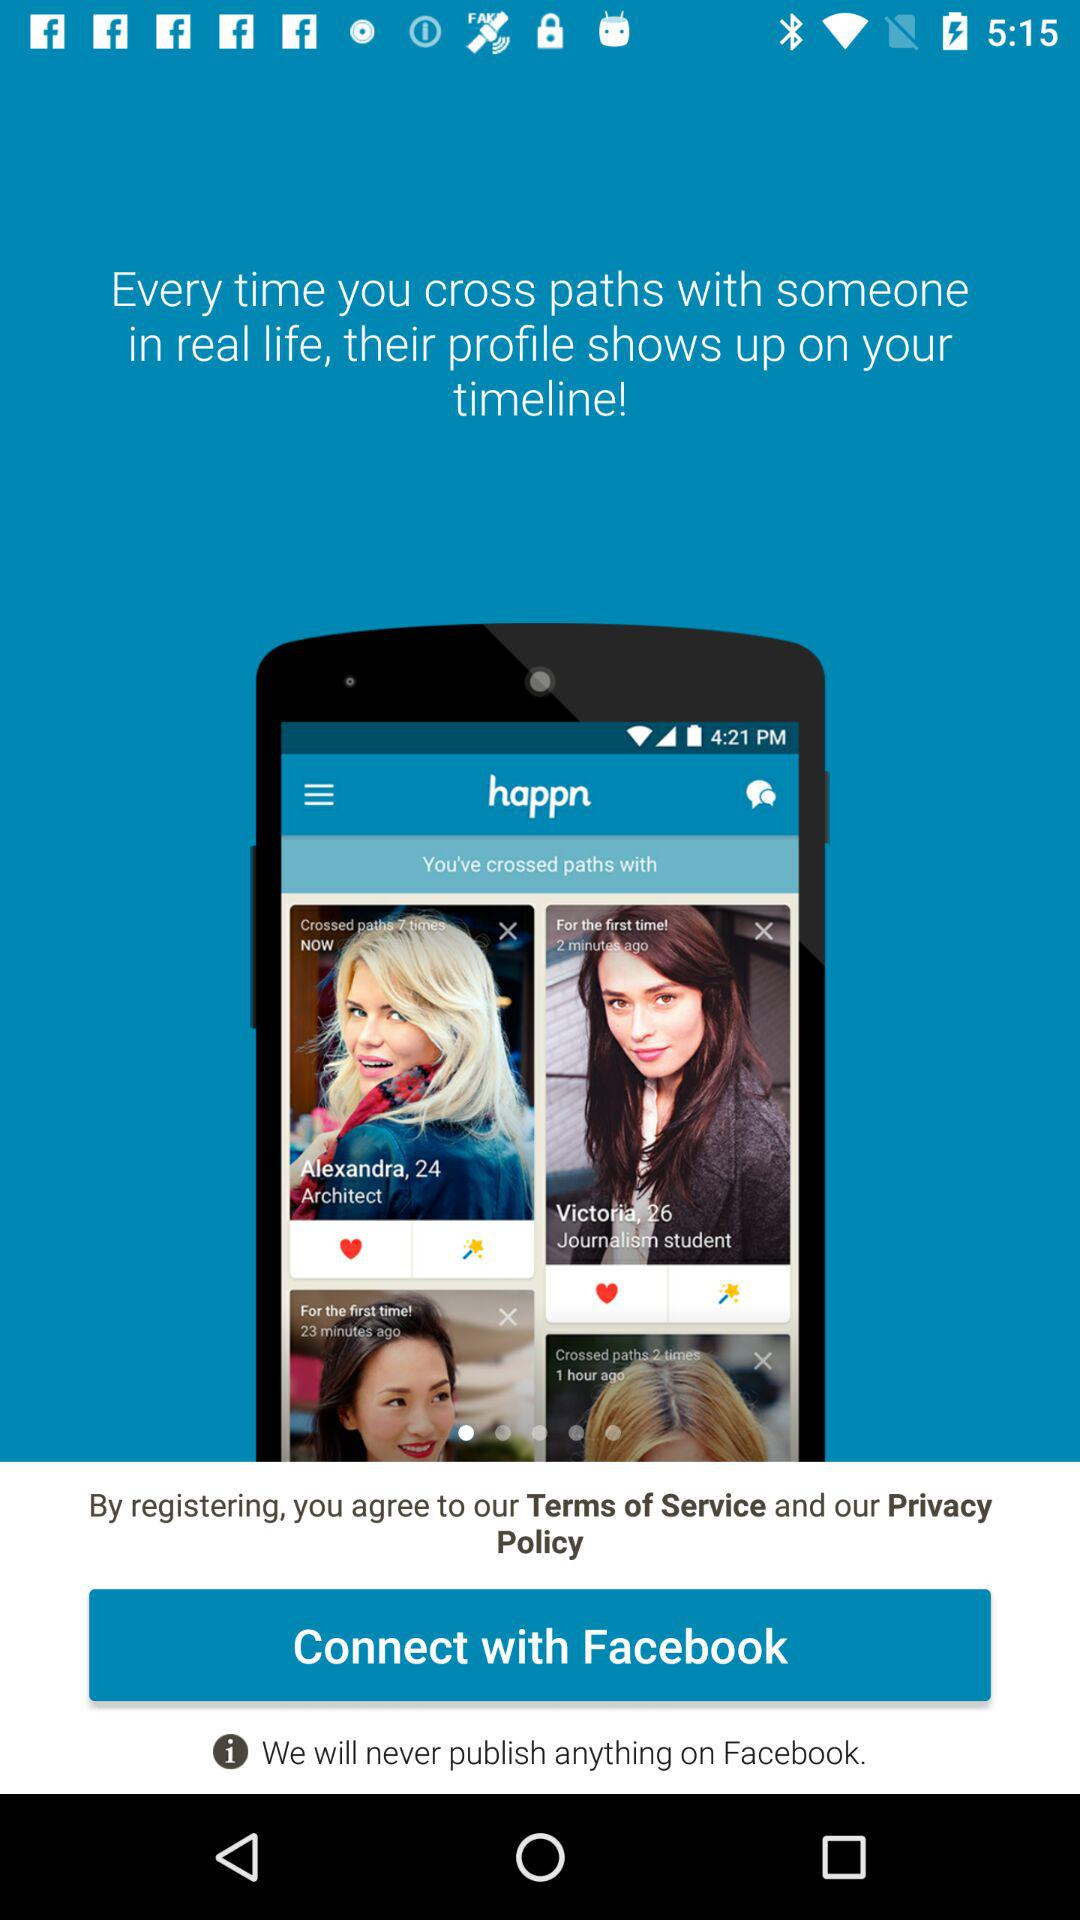How can we connect? You can connect with "Facebook". 